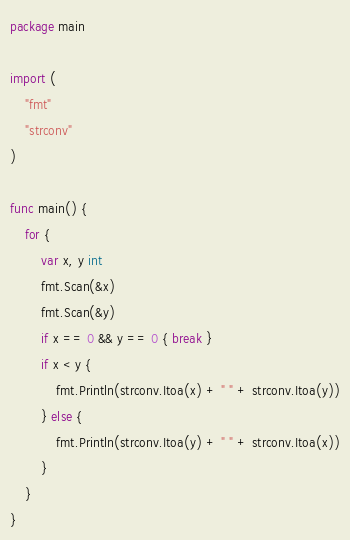Convert code to text. <code><loc_0><loc_0><loc_500><loc_500><_Go_>package main

import (
	"fmt"
	"strconv"
)

func main() {
	for {
		var x, y int
		fmt.Scan(&x)
		fmt.Scan(&y)
		if x == 0 && y == 0 { break }
		if x < y {
			fmt.Println(strconv.Itoa(x) + " " + strconv.Itoa(y))
		} else {
			fmt.Println(strconv.Itoa(y) + " " + strconv.Itoa(x))
		}
	}
}</code> 